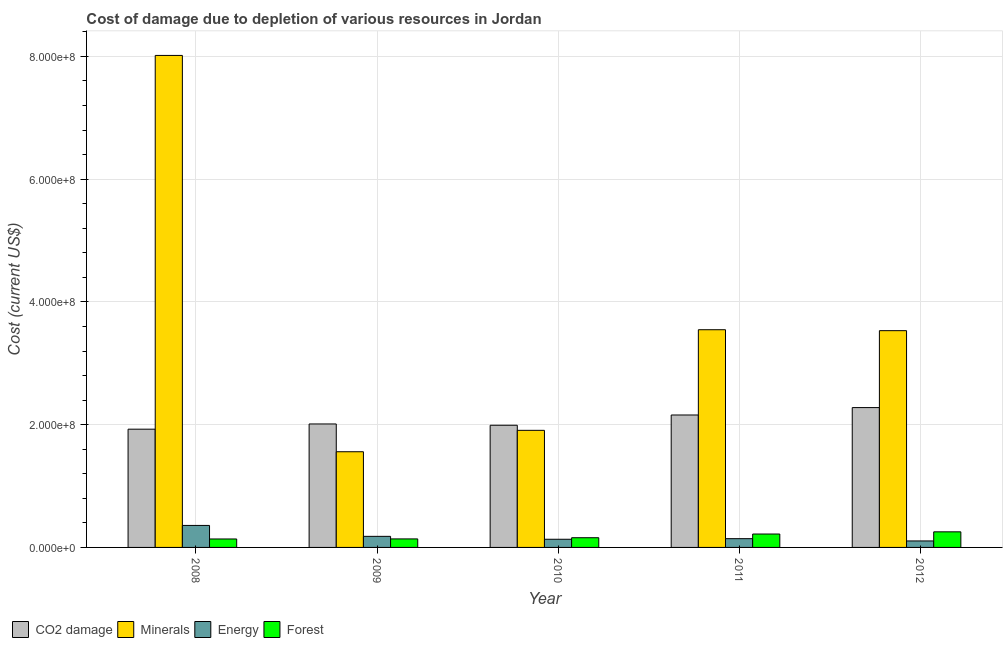How many groups of bars are there?
Your answer should be compact. 5. Are the number of bars per tick equal to the number of legend labels?
Ensure brevity in your answer.  Yes. How many bars are there on the 1st tick from the left?
Your answer should be compact. 4. How many bars are there on the 2nd tick from the right?
Make the answer very short. 4. In how many cases, is the number of bars for a given year not equal to the number of legend labels?
Offer a very short reply. 0. What is the cost of damage due to depletion of forests in 2008?
Make the answer very short. 1.38e+07. Across all years, what is the maximum cost of damage due to depletion of forests?
Your response must be concise. 2.54e+07. Across all years, what is the minimum cost of damage due to depletion of energy?
Offer a terse response. 1.06e+07. In which year was the cost of damage due to depletion of forests minimum?
Ensure brevity in your answer.  2008. What is the total cost of damage due to depletion of forests in the graph?
Your answer should be very brief. 9.07e+07. What is the difference between the cost of damage due to depletion of minerals in 2009 and that in 2011?
Keep it short and to the point. -1.99e+08. What is the difference between the cost of damage due to depletion of minerals in 2010 and the cost of damage due to depletion of energy in 2012?
Your response must be concise. -1.62e+08. What is the average cost of damage due to depletion of forests per year?
Ensure brevity in your answer.  1.81e+07. In how many years, is the cost of damage due to depletion of energy greater than 320000000 US$?
Make the answer very short. 0. What is the ratio of the cost of damage due to depletion of minerals in 2008 to that in 2009?
Provide a succinct answer. 5.14. Is the difference between the cost of damage due to depletion of forests in 2008 and 2010 greater than the difference between the cost of damage due to depletion of coal in 2008 and 2010?
Provide a succinct answer. No. What is the difference between the highest and the second highest cost of damage due to depletion of energy?
Make the answer very short. 1.78e+07. What is the difference between the highest and the lowest cost of damage due to depletion of coal?
Ensure brevity in your answer.  3.52e+07. Is it the case that in every year, the sum of the cost of damage due to depletion of minerals and cost of damage due to depletion of energy is greater than the sum of cost of damage due to depletion of forests and cost of damage due to depletion of coal?
Ensure brevity in your answer.  Yes. What does the 1st bar from the left in 2009 represents?
Make the answer very short. CO2 damage. What does the 3rd bar from the right in 2010 represents?
Your response must be concise. Minerals. How many bars are there?
Your response must be concise. 20. What is the difference between two consecutive major ticks on the Y-axis?
Give a very brief answer. 2.00e+08. Does the graph contain any zero values?
Provide a short and direct response. No. Does the graph contain grids?
Your response must be concise. Yes. Where does the legend appear in the graph?
Provide a short and direct response. Bottom left. How are the legend labels stacked?
Provide a short and direct response. Horizontal. What is the title of the graph?
Your response must be concise. Cost of damage due to depletion of various resources in Jordan . What is the label or title of the Y-axis?
Give a very brief answer. Cost (current US$). What is the Cost (current US$) in CO2 damage in 2008?
Offer a very short reply. 1.93e+08. What is the Cost (current US$) in Minerals in 2008?
Provide a succinct answer. 8.02e+08. What is the Cost (current US$) of Energy in 2008?
Your answer should be compact. 3.58e+07. What is the Cost (current US$) in Forest in 2008?
Your answer should be compact. 1.38e+07. What is the Cost (current US$) of CO2 damage in 2009?
Give a very brief answer. 2.01e+08. What is the Cost (current US$) of Minerals in 2009?
Keep it short and to the point. 1.56e+08. What is the Cost (current US$) of Energy in 2009?
Provide a succinct answer. 1.80e+07. What is the Cost (current US$) of Forest in 2009?
Your response must be concise. 1.39e+07. What is the Cost (current US$) of CO2 damage in 2010?
Your answer should be very brief. 1.99e+08. What is the Cost (current US$) in Minerals in 2010?
Your response must be concise. 1.91e+08. What is the Cost (current US$) of Energy in 2010?
Keep it short and to the point. 1.33e+07. What is the Cost (current US$) of Forest in 2010?
Give a very brief answer. 1.58e+07. What is the Cost (current US$) in CO2 damage in 2011?
Offer a terse response. 2.16e+08. What is the Cost (current US$) in Minerals in 2011?
Offer a terse response. 3.55e+08. What is the Cost (current US$) of Energy in 2011?
Provide a succinct answer. 1.43e+07. What is the Cost (current US$) in Forest in 2011?
Give a very brief answer. 2.18e+07. What is the Cost (current US$) in CO2 damage in 2012?
Offer a terse response. 2.28e+08. What is the Cost (current US$) of Minerals in 2012?
Your answer should be compact. 3.53e+08. What is the Cost (current US$) of Energy in 2012?
Your response must be concise. 1.06e+07. What is the Cost (current US$) of Forest in 2012?
Give a very brief answer. 2.54e+07. Across all years, what is the maximum Cost (current US$) of CO2 damage?
Keep it short and to the point. 2.28e+08. Across all years, what is the maximum Cost (current US$) of Minerals?
Provide a short and direct response. 8.02e+08. Across all years, what is the maximum Cost (current US$) in Energy?
Your answer should be compact. 3.58e+07. Across all years, what is the maximum Cost (current US$) in Forest?
Make the answer very short. 2.54e+07. Across all years, what is the minimum Cost (current US$) in CO2 damage?
Make the answer very short. 1.93e+08. Across all years, what is the minimum Cost (current US$) of Minerals?
Your answer should be very brief. 1.56e+08. Across all years, what is the minimum Cost (current US$) of Energy?
Your response must be concise. 1.06e+07. Across all years, what is the minimum Cost (current US$) of Forest?
Offer a terse response. 1.38e+07. What is the total Cost (current US$) in CO2 damage in the graph?
Your answer should be compact. 1.04e+09. What is the total Cost (current US$) of Minerals in the graph?
Your answer should be compact. 1.86e+09. What is the total Cost (current US$) in Energy in the graph?
Offer a terse response. 9.20e+07. What is the total Cost (current US$) in Forest in the graph?
Make the answer very short. 9.07e+07. What is the difference between the Cost (current US$) of CO2 damage in 2008 and that in 2009?
Provide a succinct answer. -8.49e+06. What is the difference between the Cost (current US$) in Minerals in 2008 and that in 2009?
Ensure brevity in your answer.  6.46e+08. What is the difference between the Cost (current US$) in Energy in 2008 and that in 2009?
Offer a very short reply. 1.78e+07. What is the difference between the Cost (current US$) in Forest in 2008 and that in 2009?
Provide a short and direct response. -1.09e+05. What is the difference between the Cost (current US$) in CO2 damage in 2008 and that in 2010?
Offer a terse response. -6.40e+06. What is the difference between the Cost (current US$) in Minerals in 2008 and that in 2010?
Ensure brevity in your answer.  6.11e+08. What is the difference between the Cost (current US$) of Energy in 2008 and that in 2010?
Your answer should be compact. 2.25e+07. What is the difference between the Cost (current US$) of Forest in 2008 and that in 2010?
Offer a terse response. -2.06e+06. What is the difference between the Cost (current US$) in CO2 damage in 2008 and that in 2011?
Ensure brevity in your answer.  -2.31e+07. What is the difference between the Cost (current US$) of Minerals in 2008 and that in 2011?
Give a very brief answer. 4.47e+08. What is the difference between the Cost (current US$) of Energy in 2008 and that in 2011?
Make the answer very short. 2.16e+07. What is the difference between the Cost (current US$) in Forest in 2008 and that in 2011?
Give a very brief answer. -8.07e+06. What is the difference between the Cost (current US$) of CO2 damage in 2008 and that in 2012?
Give a very brief answer. -3.52e+07. What is the difference between the Cost (current US$) of Minerals in 2008 and that in 2012?
Provide a succinct answer. 4.48e+08. What is the difference between the Cost (current US$) in Energy in 2008 and that in 2012?
Make the answer very short. 2.53e+07. What is the difference between the Cost (current US$) in Forest in 2008 and that in 2012?
Ensure brevity in your answer.  -1.17e+07. What is the difference between the Cost (current US$) in CO2 damage in 2009 and that in 2010?
Ensure brevity in your answer.  2.09e+06. What is the difference between the Cost (current US$) in Minerals in 2009 and that in 2010?
Give a very brief answer. -3.49e+07. What is the difference between the Cost (current US$) in Energy in 2009 and that in 2010?
Make the answer very short. 4.74e+06. What is the difference between the Cost (current US$) of Forest in 2009 and that in 2010?
Your response must be concise. -1.95e+06. What is the difference between the Cost (current US$) in CO2 damage in 2009 and that in 2011?
Ensure brevity in your answer.  -1.46e+07. What is the difference between the Cost (current US$) in Minerals in 2009 and that in 2011?
Offer a terse response. -1.99e+08. What is the difference between the Cost (current US$) in Energy in 2009 and that in 2011?
Make the answer very short. 3.79e+06. What is the difference between the Cost (current US$) in Forest in 2009 and that in 2011?
Your answer should be very brief. -7.96e+06. What is the difference between the Cost (current US$) of CO2 damage in 2009 and that in 2012?
Offer a terse response. -2.67e+07. What is the difference between the Cost (current US$) in Minerals in 2009 and that in 2012?
Your answer should be very brief. -1.97e+08. What is the difference between the Cost (current US$) in Energy in 2009 and that in 2012?
Make the answer very short. 7.49e+06. What is the difference between the Cost (current US$) of Forest in 2009 and that in 2012?
Provide a short and direct response. -1.15e+07. What is the difference between the Cost (current US$) in CO2 damage in 2010 and that in 2011?
Make the answer very short. -1.67e+07. What is the difference between the Cost (current US$) in Minerals in 2010 and that in 2011?
Your response must be concise. -1.64e+08. What is the difference between the Cost (current US$) in Energy in 2010 and that in 2011?
Offer a very short reply. -9.54e+05. What is the difference between the Cost (current US$) in Forest in 2010 and that in 2011?
Your answer should be compact. -6.01e+06. What is the difference between the Cost (current US$) in CO2 damage in 2010 and that in 2012?
Your answer should be compact. -2.88e+07. What is the difference between the Cost (current US$) in Minerals in 2010 and that in 2012?
Make the answer very short. -1.62e+08. What is the difference between the Cost (current US$) in Energy in 2010 and that in 2012?
Your answer should be compact. 2.75e+06. What is the difference between the Cost (current US$) of Forest in 2010 and that in 2012?
Keep it short and to the point. -9.60e+06. What is the difference between the Cost (current US$) in CO2 damage in 2011 and that in 2012?
Your response must be concise. -1.21e+07. What is the difference between the Cost (current US$) in Minerals in 2011 and that in 2012?
Offer a very short reply. 1.52e+06. What is the difference between the Cost (current US$) in Energy in 2011 and that in 2012?
Give a very brief answer. 3.71e+06. What is the difference between the Cost (current US$) in Forest in 2011 and that in 2012?
Give a very brief answer. -3.59e+06. What is the difference between the Cost (current US$) of CO2 damage in 2008 and the Cost (current US$) of Minerals in 2009?
Provide a succinct answer. 3.68e+07. What is the difference between the Cost (current US$) of CO2 damage in 2008 and the Cost (current US$) of Energy in 2009?
Offer a very short reply. 1.75e+08. What is the difference between the Cost (current US$) of CO2 damage in 2008 and the Cost (current US$) of Forest in 2009?
Make the answer very short. 1.79e+08. What is the difference between the Cost (current US$) of Minerals in 2008 and the Cost (current US$) of Energy in 2009?
Your response must be concise. 7.83e+08. What is the difference between the Cost (current US$) of Minerals in 2008 and the Cost (current US$) of Forest in 2009?
Offer a terse response. 7.88e+08. What is the difference between the Cost (current US$) of Energy in 2008 and the Cost (current US$) of Forest in 2009?
Ensure brevity in your answer.  2.20e+07. What is the difference between the Cost (current US$) of CO2 damage in 2008 and the Cost (current US$) of Minerals in 2010?
Keep it short and to the point. 1.89e+06. What is the difference between the Cost (current US$) of CO2 damage in 2008 and the Cost (current US$) of Energy in 2010?
Give a very brief answer. 1.79e+08. What is the difference between the Cost (current US$) of CO2 damage in 2008 and the Cost (current US$) of Forest in 2010?
Provide a succinct answer. 1.77e+08. What is the difference between the Cost (current US$) in Minerals in 2008 and the Cost (current US$) in Energy in 2010?
Make the answer very short. 7.88e+08. What is the difference between the Cost (current US$) in Minerals in 2008 and the Cost (current US$) in Forest in 2010?
Your answer should be very brief. 7.86e+08. What is the difference between the Cost (current US$) in Energy in 2008 and the Cost (current US$) in Forest in 2010?
Your answer should be compact. 2.00e+07. What is the difference between the Cost (current US$) of CO2 damage in 2008 and the Cost (current US$) of Minerals in 2011?
Keep it short and to the point. -1.62e+08. What is the difference between the Cost (current US$) of CO2 damage in 2008 and the Cost (current US$) of Energy in 2011?
Your response must be concise. 1.78e+08. What is the difference between the Cost (current US$) in CO2 damage in 2008 and the Cost (current US$) in Forest in 2011?
Make the answer very short. 1.71e+08. What is the difference between the Cost (current US$) in Minerals in 2008 and the Cost (current US$) in Energy in 2011?
Keep it short and to the point. 7.87e+08. What is the difference between the Cost (current US$) in Minerals in 2008 and the Cost (current US$) in Forest in 2011?
Ensure brevity in your answer.  7.80e+08. What is the difference between the Cost (current US$) in Energy in 2008 and the Cost (current US$) in Forest in 2011?
Provide a short and direct response. 1.40e+07. What is the difference between the Cost (current US$) in CO2 damage in 2008 and the Cost (current US$) in Minerals in 2012?
Ensure brevity in your answer.  -1.60e+08. What is the difference between the Cost (current US$) in CO2 damage in 2008 and the Cost (current US$) in Energy in 2012?
Offer a very short reply. 1.82e+08. What is the difference between the Cost (current US$) of CO2 damage in 2008 and the Cost (current US$) of Forest in 2012?
Your answer should be compact. 1.67e+08. What is the difference between the Cost (current US$) in Minerals in 2008 and the Cost (current US$) in Energy in 2012?
Keep it short and to the point. 7.91e+08. What is the difference between the Cost (current US$) of Minerals in 2008 and the Cost (current US$) of Forest in 2012?
Your answer should be very brief. 7.76e+08. What is the difference between the Cost (current US$) of Energy in 2008 and the Cost (current US$) of Forest in 2012?
Keep it short and to the point. 1.04e+07. What is the difference between the Cost (current US$) in CO2 damage in 2009 and the Cost (current US$) in Minerals in 2010?
Give a very brief answer. 1.04e+07. What is the difference between the Cost (current US$) in CO2 damage in 2009 and the Cost (current US$) in Energy in 2010?
Offer a terse response. 1.88e+08. What is the difference between the Cost (current US$) in CO2 damage in 2009 and the Cost (current US$) in Forest in 2010?
Keep it short and to the point. 1.85e+08. What is the difference between the Cost (current US$) in Minerals in 2009 and the Cost (current US$) in Energy in 2010?
Your answer should be very brief. 1.43e+08. What is the difference between the Cost (current US$) of Minerals in 2009 and the Cost (current US$) of Forest in 2010?
Offer a very short reply. 1.40e+08. What is the difference between the Cost (current US$) of Energy in 2009 and the Cost (current US$) of Forest in 2010?
Provide a succinct answer. 2.23e+06. What is the difference between the Cost (current US$) of CO2 damage in 2009 and the Cost (current US$) of Minerals in 2011?
Give a very brief answer. -1.54e+08. What is the difference between the Cost (current US$) of CO2 damage in 2009 and the Cost (current US$) of Energy in 2011?
Make the answer very short. 1.87e+08. What is the difference between the Cost (current US$) in CO2 damage in 2009 and the Cost (current US$) in Forest in 2011?
Give a very brief answer. 1.79e+08. What is the difference between the Cost (current US$) in Minerals in 2009 and the Cost (current US$) in Energy in 2011?
Make the answer very short. 1.42e+08. What is the difference between the Cost (current US$) of Minerals in 2009 and the Cost (current US$) of Forest in 2011?
Provide a succinct answer. 1.34e+08. What is the difference between the Cost (current US$) in Energy in 2009 and the Cost (current US$) in Forest in 2011?
Your answer should be compact. -3.78e+06. What is the difference between the Cost (current US$) of CO2 damage in 2009 and the Cost (current US$) of Minerals in 2012?
Offer a terse response. -1.52e+08. What is the difference between the Cost (current US$) of CO2 damage in 2009 and the Cost (current US$) of Energy in 2012?
Offer a terse response. 1.91e+08. What is the difference between the Cost (current US$) in CO2 damage in 2009 and the Cost (current US$) in Forest in 2012?
Make the answer very short. 1.76e+08. What is the difference between the Cost (current US$) in Minerals in 2009 and the Cost (current US$) in Energy in 2012?
Make the answer very short. 1.45e+08. What is the difference between the Cost (current US$) of Minerals in 2009 and the Cost (current US$) of Forest in 2012?
Provide a short and direct response. 1.30e+08. What is the difference between the Cost (current US$) of Energy in 2009 and the Cost (current US$) of Forest in 2012?
Make the answer very short. -7.36e+06. What is the difference between the Cost (current US$) in CO2 damage in 2010 and the Cost (current US$) in Minerals in 2011?
Your answer should be compact. -1.56e+08. What is the difference between the Cost (current US$) in CO2 damage in 2010 and the Cost (current US$) in Energy in 2011?
Offer a terse response. 1.85e+08. What is the difference between the Cost (current US$) of CO2 damage in 2010 and the Cost (current US$) of Forest in 2011?
Your response must be concise. 1.77e+08. What is the difference between the Cost (current US$) of Minerals in 2010 and the Cost (current US$) of Energy in 2011?
Offer a terse response. 1.76e+08. What is the difference between the Cost (current US$) in Minerals in 2010 and the Cost (current US$) in Forest in 2011?
Make the answer very short. 1.69e+08. What is the difference between the Cost (current US$) in Energy in 2010 and the Cost (current US$) in Forest in 2011?
Ensure brevity in your answer.  -8.52e+06. What is the difference between the Cost (current US$) in CO2 damage in 2010 and the Cost (current US$) in Minerals in 2012?
Your answer should be compact. -1.54e+08. What is the difference between the Cost (current US$) of CO2 damage in 2010 and the Cost (current US$) of Energy in 2012?
Ensure brevity in your answer.  1.88e+08. What is the difference between the Cost (current US$) of CO2 damage in 2010 and the Cost (current US$) of Forest in 2012?
Offer a very short reply. 1.74e+08. What is the difference between the Cost (current US$) in Minerals in 2010 and the Cost (current US$) in Energy in 2012?
Your answer should be very brief. 1.80e+08. What is the difference between the Cost (current US$) in Minerals in 2010 and the Cost (current US$) in Forest in 2012?
Offer a very short reply. 1.65e+08. What is the difference between the Cost (current US$) of Energy in 2010 and the Cost (current US$) of Forest in 2012?
Ensure brevity in your answer.  -1.21e+07. What is the difference between the Cost (current US$) in CO2 damage in 2011 and the Cost (current US$) in Minerals in 2012?
Provide a short and direct response. -1.37e+08. What is the difference between the Cost (current US$) of CO2 damage in 2011 and the Cost (current US$) of Energy in 2012?
Provide a short and direct response. 2.05e+08. What is the difference between the Cost (current US$) of CO2 damage in 2011 and the Cost (current US$) of Forest in 2012?
Provide a short and direct response. 1.90e+08. What is the difference between the Cost (current US$) of Minerals in 2011 and the Cost (current US$) of Energy in 2012?
Keep it short and to the point. 3.44e+08. What is the difference between the Cost (current US$) in Minerals in 2011 and the Cost (current US$) in Forest in 2012?
Make the answer very short. 3.29e+08. What is the difference between the Cost (current US$) in Energy in 2011 and the Cost (current US$) in Forest in 2012?
Keep it short and to the point. -1.11e+07. What is the average Cost (current US$) of CO2 damage per year?
Provide a succinct answer. 2.07e+08. What is the average Cost (current US$) of Minerals per year?
Give a very brief answer. 3.71e+08. What is the average Cost (current US$) in Energy per year?
Offer a terse response. 1.84e+07. What is the average Cost (current US$) of Forest per year?
Provide a short and direct response. 1.81e+07. In the year 2008, what is the difference between the Cost (current US$) of CO2 damage and Cost (current US$) of Minerals?
Offer a very short reply. -6.09e+08. In the year 2008, what is the difference between the Cost (current US$) in CO2 damage and Cost (current US$) in Energy?
Make the answer very short. 1.57e+08. In the year 2008, what is the difference between the Cost (current US$) in CO2 damage and Cost (current US$) in Forest?
Provide a succinct answer. 1.79e+08. In the year 2008, what is the difference between the Cost (current US$) of Minerals and Cost (current US$) of Energy?
Keep it short and to the point. 7.66e+08. In the year 2008, what is the difference between the Cost (current US$) in Minerals and Cost (current US$) in Forest?
Ensure brevity in your answer.  7.88e+08. In the year 2008, what is the difference between the Cost (current US$) in Energy and Cost (current US$) in Forest?
Give a very brief answer. 2.21e+07. In the year 2009, what is the difference between the Cost (current US$) in CO2 damage and Cost (current US$) in Minerals?
Your answer should be compact. 4.53e+07. In the year 2009, what is the difference between the Cost (current US$) in CO2 damage and Cost (current US$) in Energy?
Offer a very short reply. 1.83e+08. In the year 2009, what is the difference between the Cost (current US$) of CO2 damage and Cost (current US$) of Forest?
Provide a succinct answer. 1.87e+08. In the year 2009, what is the difference between the Cost (current US$) in Minerals and Cost (current US$) in Energy?
Offer a terse response. 1.38e+08. In the year 2009, what is the difference between the Cost (current US$) in Minerals and Cost (current US$) in Forest?
Give a very brief answer. 1.42e+08. In the year 2009, what is the difference between the Cost (current US$) in Energy and Cost (current US$) in Forest?
Offer a very short reply. 4.19e+06. In the year 2010, what is the difference between the Cost (current US$) in CO2 damage and Cost (current US$) in Minerals?
Give a very brief answer. 8.30e+06. In the year 2010, what is the difference between the Cost (current US$) of CO2 damage and Cost (current US$) of Energy?
Ensure brevity in your answer.  1.86e+08. In the year 2010, what is the difference between the Cost (current US$) in CO2 damage and Cost (current US$) in Forest?
Your answer should be compact. 1.83e+08. In the year 2010, what is the difference between the Cost (current US$) in Minerals and Cost (current US$) in Energy?
Keep it short and to the point. 1.77e+08. In the year 2010, what is the difference between the Cost (current US$) in Minerals and Cost (current US$) in Forest?
Ensure brevity in your answer.  1.75e+08. In the year 2010, what is the difference between the Cost (current US$) of Energy and Cost (current US$) of Forest?
Give a very brief answer. -2.51e+06. In the year 2011, what is the difference between the Cost (current US$) of CO2 damage and Cost (current US$) of Minerals?
Ensure brevity in your answer.  -1.39e+08. In the year 2011, what is the difference between the Cost (current US$) of CO2 damage and Cost (current US$) of Energy?
Your answer should be compact. 2.01e+08. In the year 2011, what is the difference between the Cost (current US$) in CO2 damage and Cost (current US$) in Forest?
Your answer should be compact. 1.94e+08. In the year 2011, what is the difference between the Cost (current US$) in Minerals and Cost (current US$) in Energy?
Keep it short and to the point. 3.40e+08. In the year 2011, what is the difference between the Cost (current US$) of Minerals and Cost (current US$) of Forest?
Give a very brief answer. 3.33e+08. In the year 2011, what is the difference between the Cost (current US$) in Energy and Cost (current US$) in Forest?
Provide a succinct answer. -7.56e+06. In the year 2012, what is the difference between the Cost (current US$) in CO2 damage and Cost (current US$) in Minerals?
Ensure brevity in your answer.  -1.25e+08. In the year 2012, what is the difference between the Cost (current US$) in CO2 damage and Cost (current US$) in Energy?
Your response must be concise. 2.17e+08. In the year 2012, what is the difference between the Cost (current US$) in CO2 damage and Cost (current US$) in Forest?
Your answer should be compact. 2.02e+08. In the year 2012, what is the difference between the Cost (current US$) of Minerals and Cost (current US$) of Energy?
Give a very brief answer. 3.43e+08. In the year 2012, what is the difference between the Cost (current US$) of Minerals and Cost (current US$) of Forest?
Offer a terse response. 3.28e+08. In the year 2012, what is the difference between the Cost (current US$) of Energy and Cost (current US$) of Forest?
Your answer should be compact. -1.49e+07. What is the ratio of the Cost (current US$) of CO2 damage in 2008 to that in 2009?
Provide a succinct answer. 0.96. What is the ratio of the Cost (current US$) in Minerals in 2008 to that in 2009?
Your answer should be compact. 5.14. What is the ratio of the Cost (current US$) in Energy in 2008 to that in 2009?
Make the answer very short. 1.99. What is the ratio of the Cost (current US$) in CO2 damage in 2008 to that in 2010?
Your answer should be compact. 0.97. What is the ratio of the Cost (current US$) of Minerals in 2008 to that in 2010?
Your response must be concise. 4.2. What is the ratio of the Cost (current US$) of Energy in 2008 to that in 2010?
Make the answer very short. 2.69. What is the ratio of the Cost (current US$) of Forest in 2008 to that in 2010?
Provide a short and direct response. 0.87. What is the ratio of the Cost (current US$) in CO2 damage in 2008 to that in 2011?
Make the answer very short. 0.89. What is the ratio of the Cost (current US$) of Minerals in 2008 to that in 2011?
Ensure brevity in your answer.  2.26. What is the ratio of the Cost (current US$) in Energy in 2008 to that in 2011?
Your response must be concise. 2.51. What is the ratio of the Cost (current US$) of Forest in 2008 to that in 2011?
Your response must be concise. 0.63. What is the ratio of the Cost (current US$) in CO2 damage in 2008 to that in 2012?
Your answer should be compact. 0.85. What is the ratio of the Cost (current US$) of Minerals in 2008 to that in 2012?
Offer a terse response. 2.27. What is the ratio of the Cost (current US$) of Energy in 2008 to that in 2012?
Your response must be concise. 3.4. What is the ratio of the Cost (current US$) in Forest in 2008 to that in 2012?
Your answer should be compact. 0.54. What is the ratio of the Cost (current US$) in CO2 damage in 2009 to that in 2010?
Make the answer very short. 1.01. What is the ratio of the Cost (current US$) in Minerals in 2009 to that in 2010?
Provide a succinct answer. 0.82. What is the ratio of the Cost (current US$) in Energy in 2009 to that in 2010?
Provide a short and direct response. 1.36. What is the ratio of the Cost (current US$) in Forest in 2009 to that in 2010?
Give a very brief answer. 0.88. What is the ratio of the Cost (current US$) in CO2 damage in 2009 to that in 2011?
Make the answer very short. 0.93. What is the ratio of the Cost (current US$) in Minerals in 2009 to that in 2011?
Provide a short and direct response. 0.44. What is the ratio of the Cost (current US$) of Energy in 2009 to that in 2011?
Provide a succinct answer. 1.27. What is the ratio of the Cost (current US$) in Forest in 2009 to that in 2011?
Provide a succinct answer. 0.64. What is the ratio of the Cost (current US$) of CO2 damage in 2009 to that in 2012?
Your answer should be very brief. 0.88. What is the ratio of the Cost (current US$) of Minerals in 2009 to that in 2012?
Your answer should be very brief. 0.44. What is the ratio of the Cost (current US$) of Energy in 2009 to that in 2012?
Keep it short and to the point. 1.71. What is the ratio of the Cost (current US$) in Forest in 2009 to that in 2012?
Keep it short and to the point. 0.55. What is the ratio of the Cost (current US$) of CO2 damage in 2010 to that in 2011?
Offer a terse response. 0.92. What is the ratio of the Cost (current US$) of Minerals in 2010 to that in 2011?
Offer a very short reply. 0.54. What is the ratio of the Cost (current US$) in Energy in 2010 to that in 2011?
Your answer should be very brief. 0.93. What is the ratio of the Cost (current US$) in Forest in 2010 to that in 2011?
Your response must be concise. 0.72. What is the ratio of the Cost (current US$) in CO2 damage in 2010 to that in 2012?
Your response must be concise. 0.87. What is the ratio of the Cost (current US$) of Minerals in 2010 to that in 2012?
Make the answer very short. 0.54. What is the ratio of the Cost (current US$) in Energy in 2010 to that in 2012?
Keep it short and to the point. 1.26. What is the ratio of the Cost (current US$) of Forest in 2010 to that in 2012?
Your response must be concise. 0.62. What is the ratio of the Cost (current US$) in CO2 damage in 2011 to that in 2012?
Keep it short and to the point. 0.95. What is the ratio of the Cost (current US$) in Minerals in 2011 to that in 2012?
Your answer should be very brief. 1. What is the ratio of the Cost (current US$) in Energy in 2011 to that in 2012?
Ensure brevity in your answer.  1.35. What is the ratio of the Cost (current US$) of Forest in 2011 to that in 2012?
Provide a succinct answer. 0.86. What is the difference between the highest and the second highest Cost (current US$) in CO2 damage?
Give a very brief answer. 1.21e+07. What is the difference between the highest and the second highest Cost (current US$) in Minerals?
Your answer should be compact. 4.47e+08. What is the difference between the highest and the second highest Cost (current US$) of Energy?
Your answer should be compact. 1.78e+07. What is the difference between the highest and the second highest Cost (current US$) of Forest?
Offer a terse response. 3.59e+06. What is the difference between the highest and the lowest Cost (current US$) in CO2 damage?
Offer a terse response. 3.52e+07. What is the difference between the highest and the lowest Cost (current US$) of Minerals?
Your answer should be very brief. 6.46e+08. What is the difference between the highest and the lowest Cost (current US$) in Energy?
Your answer should be very brief. 2.53e+07. What is the difference between the highest and the lowest Cost (current US$) of Forest?
Make the answer very short. 1.17e+07. 